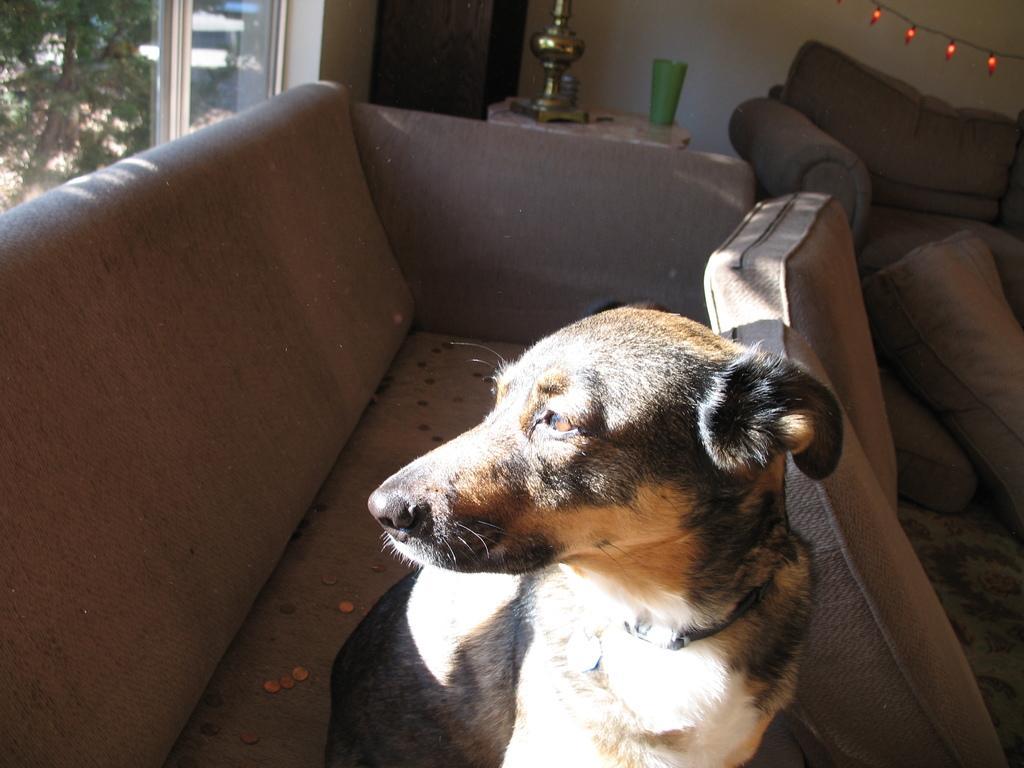How would you summarize this image in a sentence or two? In this image I can see in the middle a dog is sitting on the sofa. On the left side there are windows, outside this there are trees. On the right side there are lights in this image. 